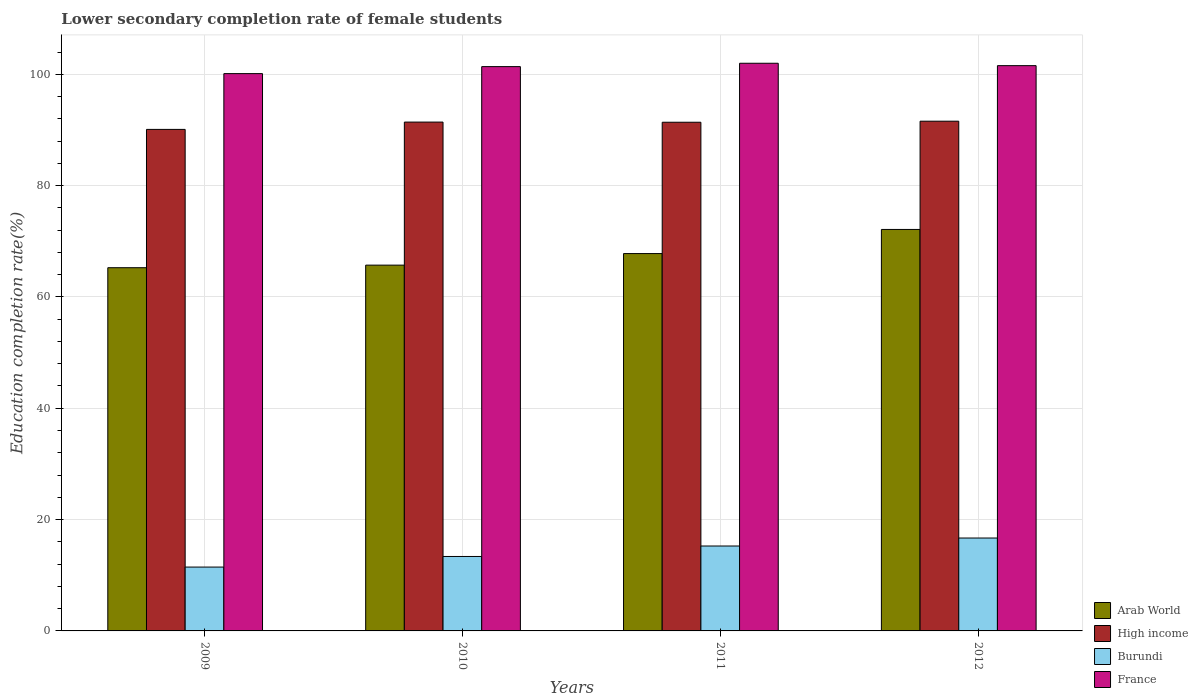How many bars are there on the 4th tick from the right?
Offer a very short reply. 4. In how many cases, is the number of bars for a given year not equal to the number of legend labels?
Keep it short and to the point. 0. What is the lower secondary completion rate of female students in High income in 2011?
Give a very brief answer. 91.38. Across all years, what is the maximum lower secondary completion rate of female students in France?
Ensure brevity in your answer.  101.98. Across all years, what is the minimum lower secondary completion rate of female students in High income?
Provide a short and direct response. 90.1. In which year was the lower secondary completion rate of female students in Burundi maximum?
Provide a succinct answer. 2012. What is the total lower secondary completion rate of female students in Arab World in the graph?
Make the answer very short. 270.87. What is the difference between the lower secondary completion rate of female students in France in 2009 and that in 2012?
Offer a very short reply. -1.43. What is the difference between the lower secondary completion rate of female students in France in 2009 and the lower secondary completion rate of female students in Arab World in 2012?
Ensure brevity in your answer.  27.99. What is the average lower secondary completion rate of female students in France per year?
Your answer should be very brief. 101.26. In the year 2009, what is the difference between the lower secondary completion rate of female students in France and lower secondary completion rate of female students in Burundi?
Ensure brevity in your answer.  88.65. In how many years, is the lower secondary completion rate of female students in Arab World greater than 80 %?
Your answer should be compact. 0. What is the ratio of the lower secondary completion rate of female students in France in 2010 to that in 2012?
Offer a terse response. 1. Is the lower secondary completion rate of female students in High income in 2011 less than that in 2012?
Your answer should be compact. Yes. What is the difference between the highest and the second highest lower secondary completion rate of female students in Burundi?
Ensure brevity in your answer.  1.43. What is the difference between the highest and the lowest lower secondary completion rate of female students in France?
Offer a very short reply. 1.86. Is the sum of the lower secondary completion rate of female students in Burundi in 2009 and 2010 greater than the maximum lower secondary completion rate of female students in France across all years?
Your answer should be very brief. No. What does the 3rd bar from the left in 2011 represents?
Your response must be concise. Burundi. What does the 2nd bar from the right in 2010 represents?
Your answer should be very brief. Burundi. Is it the case that in every year, the sum of the lower secondary completion rate of female students in France and lower secondary completion rate of female students in High income is greater than the lower secondary completion rate of female students in Arab World?
Provide a short and direct response. Yes. How many bars are there?
Your answer should be compact. 16. How many years are there in the graph?
Make the answer very short. 4. Are the values on the major ticks of Y-axis written in scientific E-notation?
Give a very brief answer. No. Does the graph contain any zero values?
Offer a terse response. No. What is the title of the graph?
Provide a short and direct response. Lower secondary completion rate of female students. Does "Uruguay" appear as one of the legend labels in the graph?
Your response must be concise. No. What is the label or title of the X-axis?
Your answer should be compact. Years. What is the label or title of the Y-axis?
Your response must be concise. Education completion rate(%). What is the Education completion rate(%) of Arab World in 2009?
Keep it short and to the point. 65.25. What is the Education completion rate(%) in High income in 2009?
Ensure brevity in your answer.  90.1. What is the Education completion rate(%) in Burundi in 2009?
Offer a very short reply. 11.47. What is the Education completion rate(%) in France in 2009?
Make the answer very short. 100.12. What is the Education completion rate(%) of Arab World in 2010?
Your answer should be very brief. 65.71. What is the Education completion rate(%) of High income in 2010?
Give a very brief answer. 91.41. What is the Education completion rate(%) in Burundi in 2010?
Your response must be concise. 13.37. What is the Education completion rate(%) in France in 2010?
Your response must be concise. 101.37. What is the Education completion rate(%) of Arab World in 2011?
Ensure brevity in your answer.  67.79. What is the Education completion rate(%) of High income in 2011?
Make the answer very short. 91.38. What is the Education completion rate(%) of Burundi in 2011?
Offer a terse response. 15.25. What is the Education completion rate(%) of France in 2011?
Offer a very short reply. 101.98. What is the Education completion rate(%) in Arab World in 2012?
Your answer should be very brief. 72.12. What is the Education completion rate(%) in High income in 2012?
Make the answer very short. 91.57. What is the Education completion rate(%) of Burundi in 2012?
Offer a very short reply. 16.69. What is the Education completion rate(%) of France in 2012?
Your answer should be compact. 101.55. Across all years, what is the maximum Education completion rate(%) of Arab World?
Your response must be concise. 72.12. Across all years, what is the maximum Education completion rate(%) in High income?
Your answer should be compact. 91.57. Across all years, what is the maximum Education completion rate(%) in Burundi?
Your answer should be compact. 16.69. Across all years, what is the maximum Education completion rate(%) of France?
Make the answer very short. 101.98. Across all years, what is the minimum Education completion rate(%) of Arab World?
Make the answer very short. 65.25. Across all years, what is the minimum Education completion rate(%) of High income?
Provide a succinct answer. 90.1. Across all years, what is the minimum Education completion rate(%) of Burundi?
Give a very brief answer. 11.47. Across all years, what is the minimum Education completion rate(%) of France?
Your answer should be compact. 100.12. What is the total Education completion rate(%) in Arab World in the graph?
Offer a terse response. 270.87. What is the total Education completion rate(%) in High income in the graph?
Provide a succinct answer. 364.46. What is the total Education completion rate(%) in Burundi in the graph?
Your answer should be very brief. 56.78. What is the total Education completion rate(%) in France in the graph?
Your answer should be very brief. 405.02. What is the difference between the Education completion rate(%) of Arab World in 2009 and that in 2010?
Your answer should be very brief. -0.46. What is the difference between the Education completion rate(%) of High income in 2009 and that in 2010?
Provide a short and direct response. -1.31. What is the difference between the Education completion rate(%) in Burundi in 2009 and that in 2010?
Your answer should be very brief. -1.9. What is the difference between the Education completion rate(%) of France in 2009 and that in 2010?
Ensure brevity in your answer.  -1.26. What is the difference between the Education completion rate(%) of Arab World in 2009 and that in 2011?
Your answer should be very brief. -2.54. What is the difference between the Education completion rate(%) of High income in 2009 and that in 2011?
Offer a terse response. -1.29. What is the difference between the Education completion rate(%) in Burundi in 2009 and that in 2011?
Ensure brevity in your answer.  -3.78. What is the difference between the Education completion rate(%) of France in 2009 and that in 2011?
Your answer should be compact. -1.86. What is the difference between the Education completion rate(%) in Arab World in 2009 and that in 2012?
Your response must be concise. -6.87. What is the difference between the Education completion rate(%) of High income in 2009 and that in 2012?
Your response must be concise. -1.48. What is the difference between the Education completion rate(%) of Burundi in 2009 and that in 2012?
Your answer should be compact. -5.22. What is the difference between the Education completion rate(%) in France in 2009 and that in 2012?
Your response must be concise. -1.43. What is the difference between the Education completion rate(%) of Arab World in 2010 and that in 2011?
Offer a terse response. -2.08. What is the difference between the Education completion rate(%) of High income in 2010 and that in 2011?
Make the answer very short. 0.03. What is the difference between the Education completion rate(%) in Burundi in 2010 and that in 2011?
Offer a terse response. -1.88. What is the difference between the Education completion rate(%) in France in 2010 and that in 2011?
Your response must be concise. -0.6. What is the difference between the Education completion rate(%) in Arab World in 2010 and that in 2012?
Ensure brevity in your answer.  -6.41. What is the difference between the Education completion rate(%) in High income in 2010 and that in 2012?
Your answer should be compact. -0.16. What is the difference between the Education completion rate(%) in Burundi in 2010 and that in 2012?
Give a very brief answer. -3.31. What is the difference between the Education completion rate(%) in France in 2010 and that in 2012?
Ensure brevity in your answer.  -0.17. What is the difference between the Education completion rate(%) of Arab World in 2011 and that in 2012?
Provide a succinct answer. -4.33. What is the difference between the Education completion rate(%) of High income in 2011 and that in 2012?
Provide a succinct answer. -0.19. What is the difference between the Education completion rate(%) of Burundi in 2011 and that in 2012?
Your answer should be very brief. -1.43. What is the difference between the Education completion rate(%) in France in 2011 and that in 2012?
Your answer should be compact. 0.43. What is the difference between the Education completion rate(%) in Arab World in 2009 and the Education completion rate(%) in High income in 2010?
Provide a succinct answer. -26.16. What is the difference between the Education completion rate(%) of Arab World in 2009 and the Education completion rate(%) of Burundi in 2010?
Offer a very short reply. 51.88. What is the difference between the Education completion rate(%) in Arab World in 2009 and the Education completion rate(%) in France in 2010?
Your answer should be compact. -36.13. What is the difference between the Education completion rate(%) of High income in 2009 and the Education completion rate(%) of Burundi in 2010?
Provide a short and direct response. 76.72. What is the difference between the Education completion rate(%) in High income in 2009 and the Education completion rate(%) in France in 2010?
Give a very brief answer. -11.28. What is the difference between the Education completion rate(%) in Burundi in 2009 and the Education completion rate(%) in France in 2010?
Offer a terse response. -89.91. What is the difference between the Education completion rate(%) of Arab World in 2009 and the Education completion rate(%) of High income in 2011?
Your response must be concise. -26.13. What is the difference between the Education completion rate(%) in Arab World in 2009 and the Education completion rate(%) in Burundi in 2011?
Keep it short and to the point. 50. What is the difference between the Education completion rate(%) of Arab World in 2009 and the Education completion rate(%) of France in 2011?
Your answer should be very brief. -36.73. What is the difference between the Education completion rate(%) in High income in 2009 and the Education completion rate(%) in Burundi in 2011?
Offer a terse response. 74.84. What is the difference between the Education completion rate(%) in High income in 2009 and the Education completion rate(%) in France in 2011?
Provide a short and direct response. -11.88. What is the difference between the Education completion rate(%) in Burundi in 2009 and the Education completion rate(%) in France in 2011?
Offer a very short reply. -90.51. What is the difference between the Education completion rate(%) in Arab World in 2009 and the Education completion rate(%) in High income in 2012?
Provide a succinct answer. -26.32. What is the difference between the Education completion rate(%) in Arab World in 2009 and the Education completion rate(%) in Burundi in 2012?
Your answer should be compact. 48.56. What is the difference between the Education completion rate(%) of Arab World in 2009 and the Education completion rate(%) of France in 2012?
Offer a very short reply. -36.3. What is the difference between the Education completion rate(%) in High income in 2009 and the Education completion rate(%) in Burundi in 2012?
Keep it short and to the point. 73.41. What is the difference between the Education completion rate(%) of High income in 2009 and the Education completion rate(%) of France in 2012?
Offer a very short reply. -11.45. What is the difference between the Education completion rate(%) of Burundi in 2009 and the Education completion rate(%) of France in 2012?
Provide a succinct answer. -90.08. What is the difference between the Education completion rate(%) of Arab World in 2010 and the Education completion rate(%) of High income in 2011?
Keep it short and to the point. -25.67. What is the difference between the Education completion rate(%) of Arab World in 2010 and the Education completion rate(%) of Burundi in 2011?
Give a very brief answer. 50.46. What is the difference between the Education completion rate(%) in Arab World in 2010 and the Education completion rate(%) in France in 2011?
Provide a succinct answer. -36.27. What is the difference between the Education completion rate(%) of High income in 2010 and the Education completion rate(%) of Burundi in 2011?
Your answer should be very brief. 76.16. What is the difference between the Education completion rate(%) of High income in 2010 and the Education completion rate(%) of France in 2011?
Provide a succinct answer. -10.57. What is the difference between the Education completion rate(%) of Burundi in 2010 and the Education completion rate(%) of France in 2011?
Offer a very short reply. -88.6. What is the difference between the Education completion rate(%) in Arab World in 2010 and the Education completion rate(%) in High income in 2012?
Your answer should be compact. -25.86. What is the difference between the Education completion rate(%) in Arab World in 2010 and the Education completion rate(%) in Burundi in 2012?
Your response must be concise. 49.02. What is the difference between the Education completion rate(%) of Arab World in 2010 and the Education completion rate(%) of France in 2012?
Offer a terse response. -35.84. What is the difference between the Education completion rate(%) of High income in 2010 and the Education completion rate(%) of Burundi in 2012?
Provide a succinct answer. 74.72. What is the difference between the Education completion rate(%) in High income in 2010 and the Education completion rate(%) in France in 2012?
Your answer should be very brief. -10.14. What is the difference between the Education completion rate(%) in Burundi in 2010 and the Education completion rate(%) in France in 2012?
Offer a very short reply. -88.18. What is the difference between the Education completion rate(%) of Arab World in 2011 and the Education completion rate(%) of High income in 2012?
Keep it short and to the point. -23.78. What is the difference between the Education completion rate(%) in Arab World in 2011 and the Education completion rate(%) in Burundi in 2012?
Provide a short and direct response. 51.1. What is the difference between the Education completion rate(%) of Arab World in 2011 and the Education completion rate(%) of France in 2012?
Offer a very short reply. -33.76. What is the difference between the Education completion rate(%) in High income in 2011 and the Education completion rate(%) in Burundi in 2012?
Ensure brevity in your answer.  74.69. What is the difference between the Education completion rate(%) in High income in 2011 and the Education completion rate(%) in France in 2012?
Ensure brevity in your answer.  -10.17. What is the difference between the Education completion rate(%) in Burundi in 2011 and the Education completion rate(%) in France in 2012?
Offer a terse response. -86.3. What is the average Education completion rate(%) of Arab World per year?
Offer a terse response. 67.72. What is the average Education completion rate(%) of High income per year?
Your answer should be very brief. 91.11. What is the average Education completion rate(%) in Burundi per year?
Your answer should be compact. 14.2. What is the average Education completion rate(%) of France per year?
Offer a very short reply. 101.25. In the year 2009, what is the difference between the Education completion rate(%) of Arab World and Education completion rate(%) of High income?
Ensure brevity in your answer.  -24.85. In the year 2009, what is the difference between the Education completion rate(%) in Arab World and Education completion rate(%) in Burundi?
Provide a succinct answer. 53.78. In the year 2009, what is the difference between the Education completion rate(%) of Arab World and Education completion rate(%) of France?
Offer a very short reply. -34.87. In the year 2009, what is the difference between the Education completion rate(%) of High income and Education completion rate(%) of Burundi?
Provide a short and direct response. 78.63. In the year 2009, what is the difference between the Education completion rate(%) in High income and Education completion rate(%) in France?
Your answer should be compact. -10.02. In the year 2009, what is the difference between the Education completion rate(%) in Burundi and Education completion rate(%) in France?
Your answer should be very brief. -88.65. In the year 2010, what is the difference between the Education completion rate(%) of Arab World and Education completion rate(%) of High income?
Your answer should be compact. -25.7. In the year 2010, what is the difference between the Education completion rate(%) in Arab World and Education completion rate(%) in Burundi?
Ensure brevity in your answer.  52.34. In the year 2010, what is the difference between the Education completion rate(%) of Arab World and Education completion rate(%) of France?
Your answer should be compact. -35.66. In the year 2010, what is the difference between the Education completion rate(%) of High income and Education completion rate(%) of Burundi?
Give a very brief answer. 78.04. In the year 2010, what is the difference between the Education completion rate(%) in High income and Education completion rate(%) in France?
Give a very brief answer. -9.96. In the year 2010, what is the difference between the Education completion rate(%) in Burundi and Education completion rate(%) in France?
Give a very brief answer. -88. In the year 2011, what is the difference between the Education completion rate(%) in Arab World and Education completion rate(%) in High income?
Keep it short and to the point. -23.59. In the year 2011, what is the difference between the Education completion rate(%) of Arab World and Education completion rate(%) of Burundi?
Your answer should be very brief. 52.54. In the year 2011, what is the difference between the Education completion rate(%) in Arab World and Education completion rate(%) in France?
Offer a very short reply. -34.19. In the year 2011, what is the difference between the Education completion rate(%) in High income and Education completion rate(%) in Burundi?
Provide a short and direct response. 76.13. In the year 2011, what is the difference between the Education completion rate(%) in High income and Education completion rate(%) in France?
Ensure brevity in your answer.  -10.6. In the year 2011, what is the difference between the Education completion rate(%) in Burundi and Education completion rate(%) in France?
Give a very brief answer. -86.73. In the year 2012, what is the difference between the Education completion rate(%) of Arab World and Education completion rate(%) of High income?
Give a very brief answer. -19.45. In the year 2012, what is the difference between the Education completion rate(%) in Arab World and Education completion rate(%) in Burundi?
Make the answer very short. 55.44. In the year 2012, what is the difference between the Education completion rate(%) in Arab World and Education completion rate(%) in France?
Offer a very short reply. -29.43. In the year 2012, what is the difference between the Education completion rate(%) in High income and Education completion rate(%) in Burundi?
Keep it short and to the point. 74.88. In the year 2012, what is the difference between the Education completion rate(%) in High income and Education completion rate(%) in France?
Make the answer very short. -9.98. In the year 2012, what is the difference between the Education completion rate(%) in Burundi and Education completion rate(%) in France?
Ensure brevity in your answer.  -84.86. What is the ratio of the Education completion rate(%) in High income in 2009 to that in 2010?
Provide a succinct answer. 0.99. What is the ratio of the Education completion rate(%) of Burundi in 2009 to that in 2010?
Keep it short and to the point. 0.86. What is the ratio of the Education completion rate(%) of France in 2009 to that in 2010?
Offer a very short reply. 0.99. What is the ratio of the Education completion rate(%) of Arab World in 2009 to that in 2011?
Make the answer very short. 0.96. What is the ratio of the Education completion rate(%) of High income in 2009 to that in 2011?
Ensure brevity in your answer.  0.99. What is the ratio of the Education completion rate(%) of Burundi in 2009 to that in 2011?
Your answer should be very brief. 0.75. What is the ratio of the Education completion rate(%) of France in 2009 to that in 2011?
Provide a succinct answer. 0.98. What is the ratio of the Education completion rate(%) of Arab World in 2009 to that in 2012?
Offer a very short reply. 0.9. What is the ratio of the Education completion rate(%) in High income in 2009 to that in 2012?
Your answer should be compact. 0.98. What is the ratio of the Education completion rate(%) of Burundi in 2009 to that in 2012?
Make the answer very short. 0.69. What is the ratio of the Education completion rate(%) of France in 2009 to that in 2012?
Provide a short and direct response. 0.99. What is the ratio of the Education completion rate(%) of Arab World in 2010 to that in 2011?
Your answer should be very brief. 0.97. What is the ratio of the Education completion rate(%) of High income in 2010 to that in 2011?
Keep it short and to the point. 1. What is the ratio of the Education completion rate(%) in Burundi in 2010 to that in 2011?
Your response must be concise. 0.88. What is the ratio of the Education completion rate(%) in France in 2010 to that in 2011?
Your answer should be compact. 0.99. What is the ratio of the Education completion rate(%) of Arab World in 2010 to that in 2012?
Your answer should be very brief. 0.91. What is the ratio of the Education completion rate(%) of Burundi in 2010 to that in 2012?
Your answer should be compact. 0.8. What is the ratio of the Education completion rate(%) of Arab World in 2011 to that in 2012?
Provide a succinct answer. 0.94. What is the ratio of the Education completion rate(%) in High income in 2011 to that in 2012?
Your answer should be very brief. 1. What is the ratio of the Education completion rate(%) of Burundi in 2011 to that in 2012?
Keep it short and to the point. 0.91. What is the difference between the highest and the second highest Education completion rate(%) in Arab World?
Offer a very short reply. 4.33. What is the difference between the highest and the second highest Education completion rate(%) in High income?
Give a very brief answer. 0.16. What is the difference between the highest and the second highest Education completion rate(%) in Burundi?
Your answer should be very brief. 1.43. What is the difference between the highest and the second highest Education completion rate(%) in France?
Make the answer very short. 0.43. What is the difference between the highest and the lowest Education completion rate(%) of Arab World?
Your answer should be compact. 6.87. What is the difference between the highest and the lowest Education completion rate(%) of High income?
Make the answer very short. 1.48. What is the difference between the highest and the lowest Education completion rate(%) of Burundi?
Offer a very short reply. 5.22. What is the difference between the highest and the lowest Education completion rate(%) in France?
Provide a succinct answer. 1.86. 